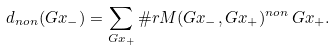Convert formula to latex. <formula><loc_0><loc_0><loc_500><loc_500>d _ { n o n } ( G x _ { - } ) = \sum _ { G x _ { + } } \# r M ( G x _ { - } , G x _ { + } ) ^ { n o n } \, G x _ { + } .</formula> 